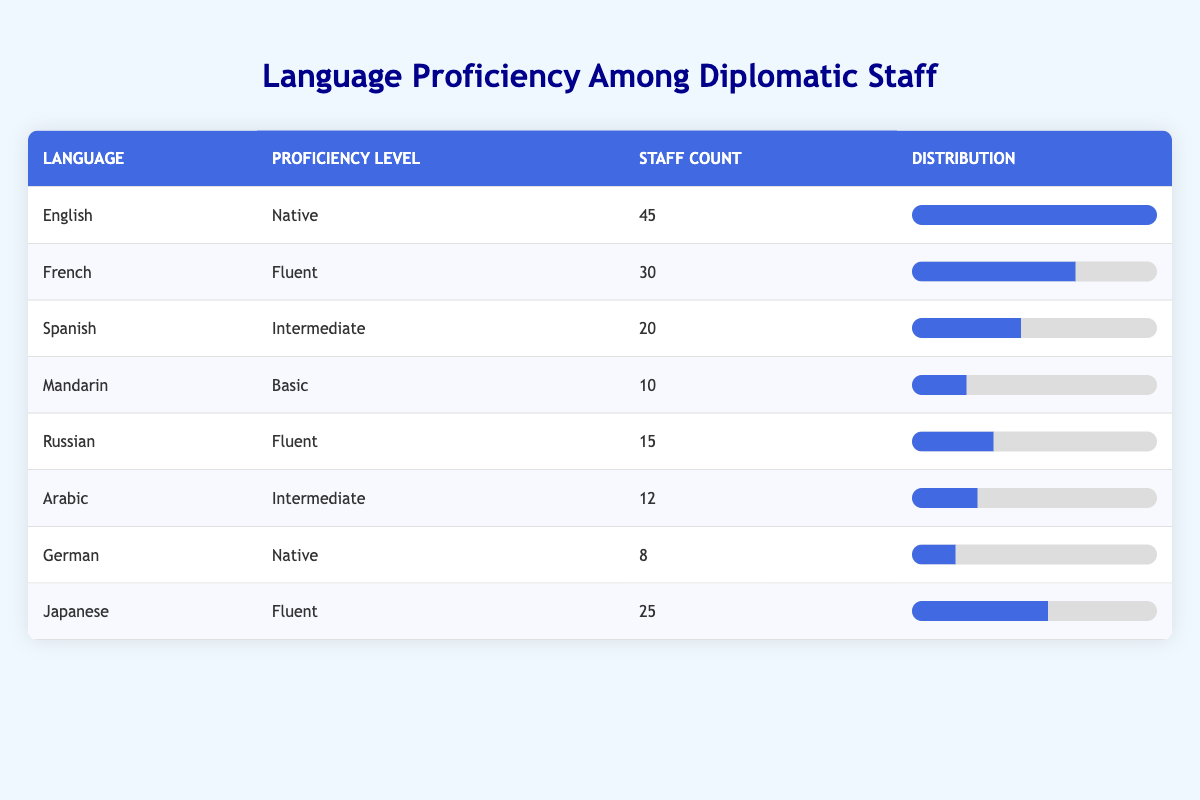What is the staff count for English proficiency? The table shows that the staff count for English proficiency is provided in the "Staff Count" column. Specifically for English, it lists 45.
Answer: 45 Which language has the highest number of fluent speakers among the staff? According to the table, French has 30 fluent speakers, Russian has 15, and Japanese has 25. Therefore, French has the highest number of fluent speakers at 30.
Answer: French What is the total staff count for languages with an intermediate proficiency level? The languages with intermediate proficiency are Spanish (20) and Arabic (12). The total staff count is calculated as 20 + 12, which equals 32.
Answer: 32 Does any language have a native proficiency level with a staff count greater than 40? The table shows that English has a native proficiency level with a staff count of 45, which is greater than 40. Therefore, the answer is yes.
Answer: Yes How many more staff members are fluent in French than in Russian? The staff count for fluent French speakers is 30 and for Russian speakers is 15. To find the difference, we subtract 15 from 30, resulting in 15 more French speakers.
Answer: 15 What percentage of the total staff speaks Mandarin at a basic level? First, we need to calculate the total staff count: 45 + 30 + 20 + 10 + 15 + 12 + 8 + 25 = 165. The count for Mandarin at a basic level is 10. To find the percentage, we use: (10 / 165) * 100, which equals approximately 6.06%.
Answer: Approximately 6.06% Which language has the least number of staff proficient at that level? Looking at the table, Mandarin has the least staff count at a basic proficiency level with only 10 staff members.
Answer: Mandarin If we compare native proficiency levels, how many staff members are proficient in German compared to English? For German, the staff count is 8, while for English, it is 45. Thus, English has 37 more staff members proficient at the native level than German.
Answer: 37 